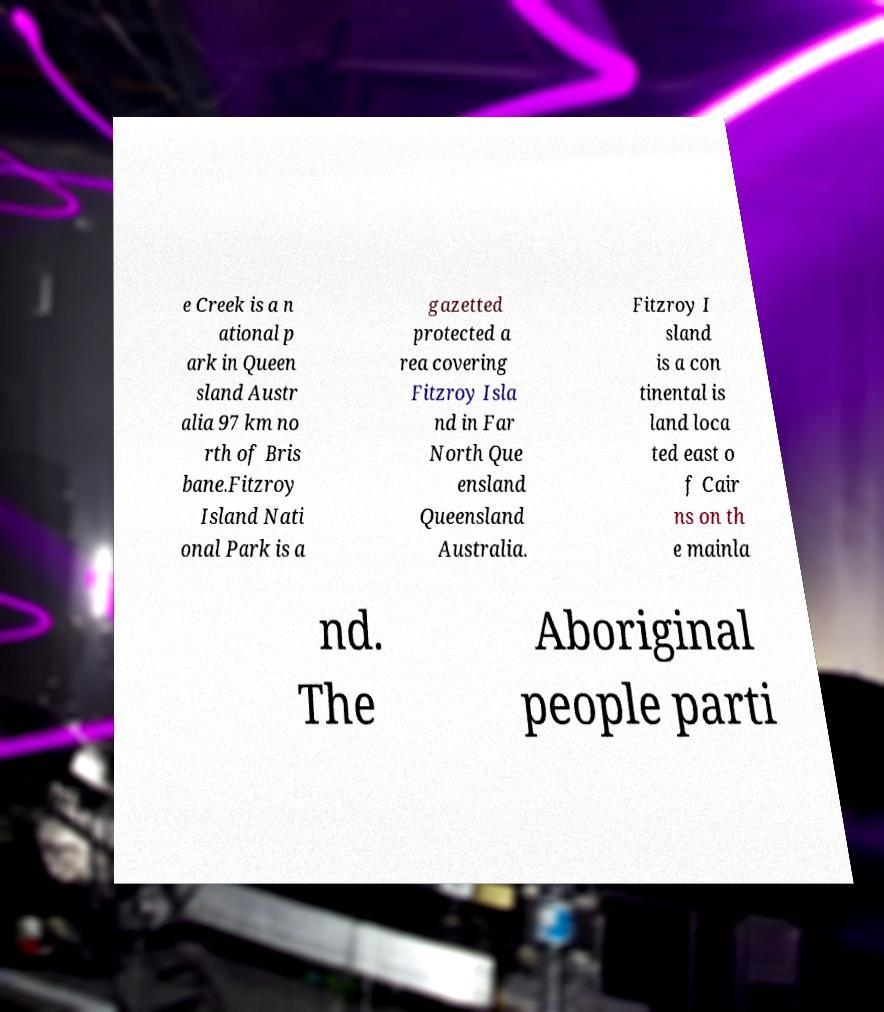I need the written content from this picture converted into text. Can you do that? e Creek is a n ational p ark in Queen sland Austr alia 97 km no rth of Bris bane.Fitzroy Island Nati onal Park is a gazetted protected a rea covering Fitzroy Isla nd in Far North Que ensland Queensland Australia. Fitzroy I sland is a con tinental is land loca ted east o f Cair ns on th e mainla nd. The Aboriginal people parti 